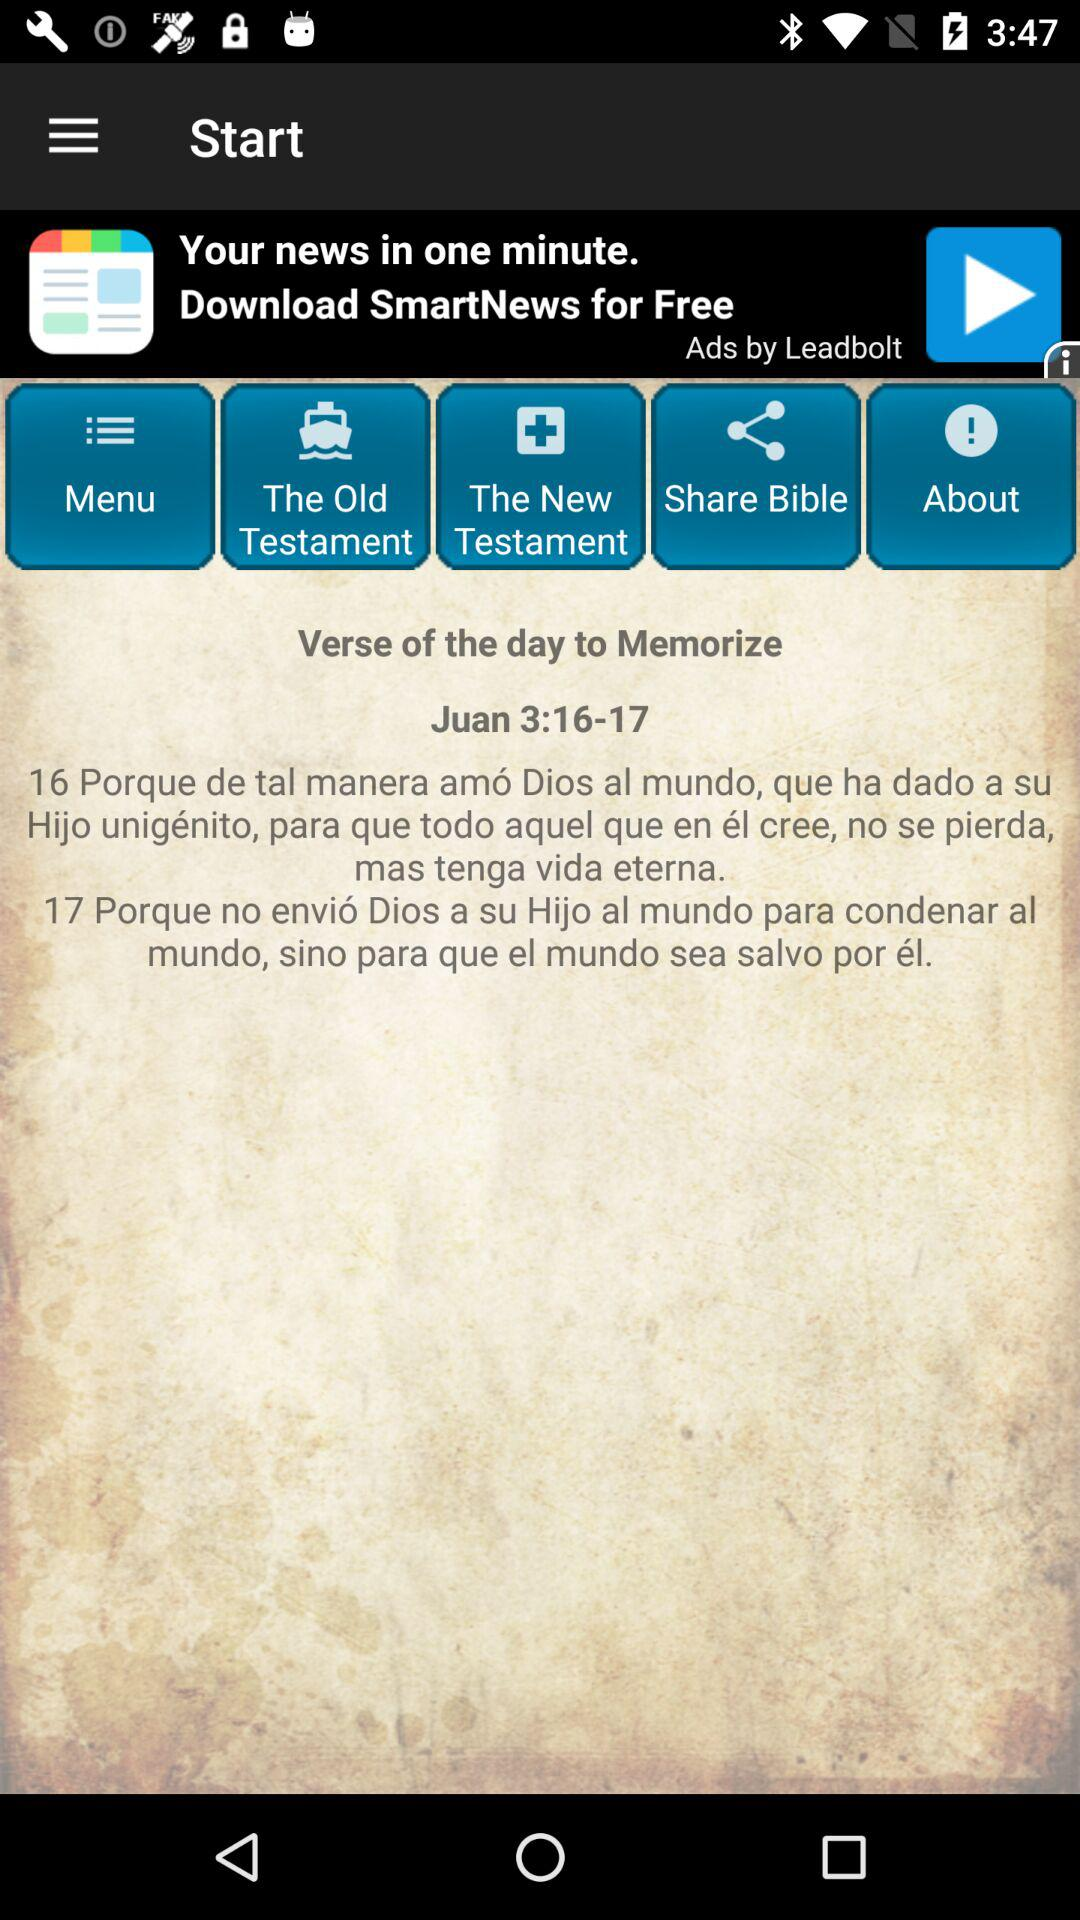What is the date given?
When the provided information is insufficient, respond with <no answer>. <no answer> 